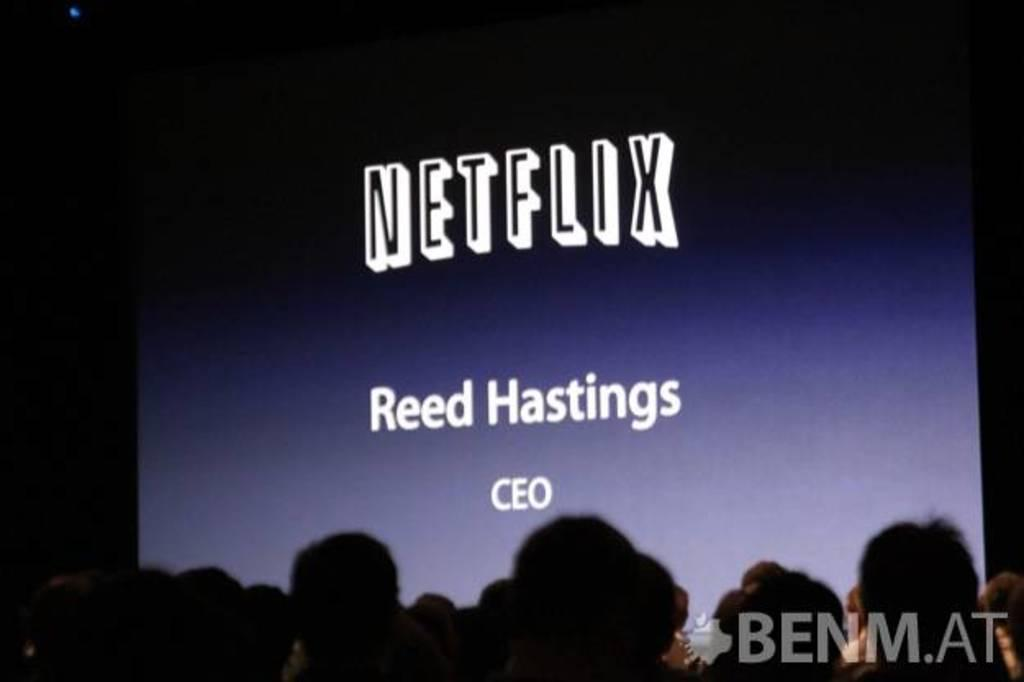What is the main object in the image? There is a screen in the image. What can be seen on the screen? There is text on the screen. Who is present in the image besides the screen? There are spectators at the bottom of the image. What are the spectators doing? The spectators are watching the screen. How many ladybugs can be seen crawling on the lace in the image? There are no ladybugs or lace present in the image. What religious symbols are visible in the image? There are no religious symbols visible in the image. 